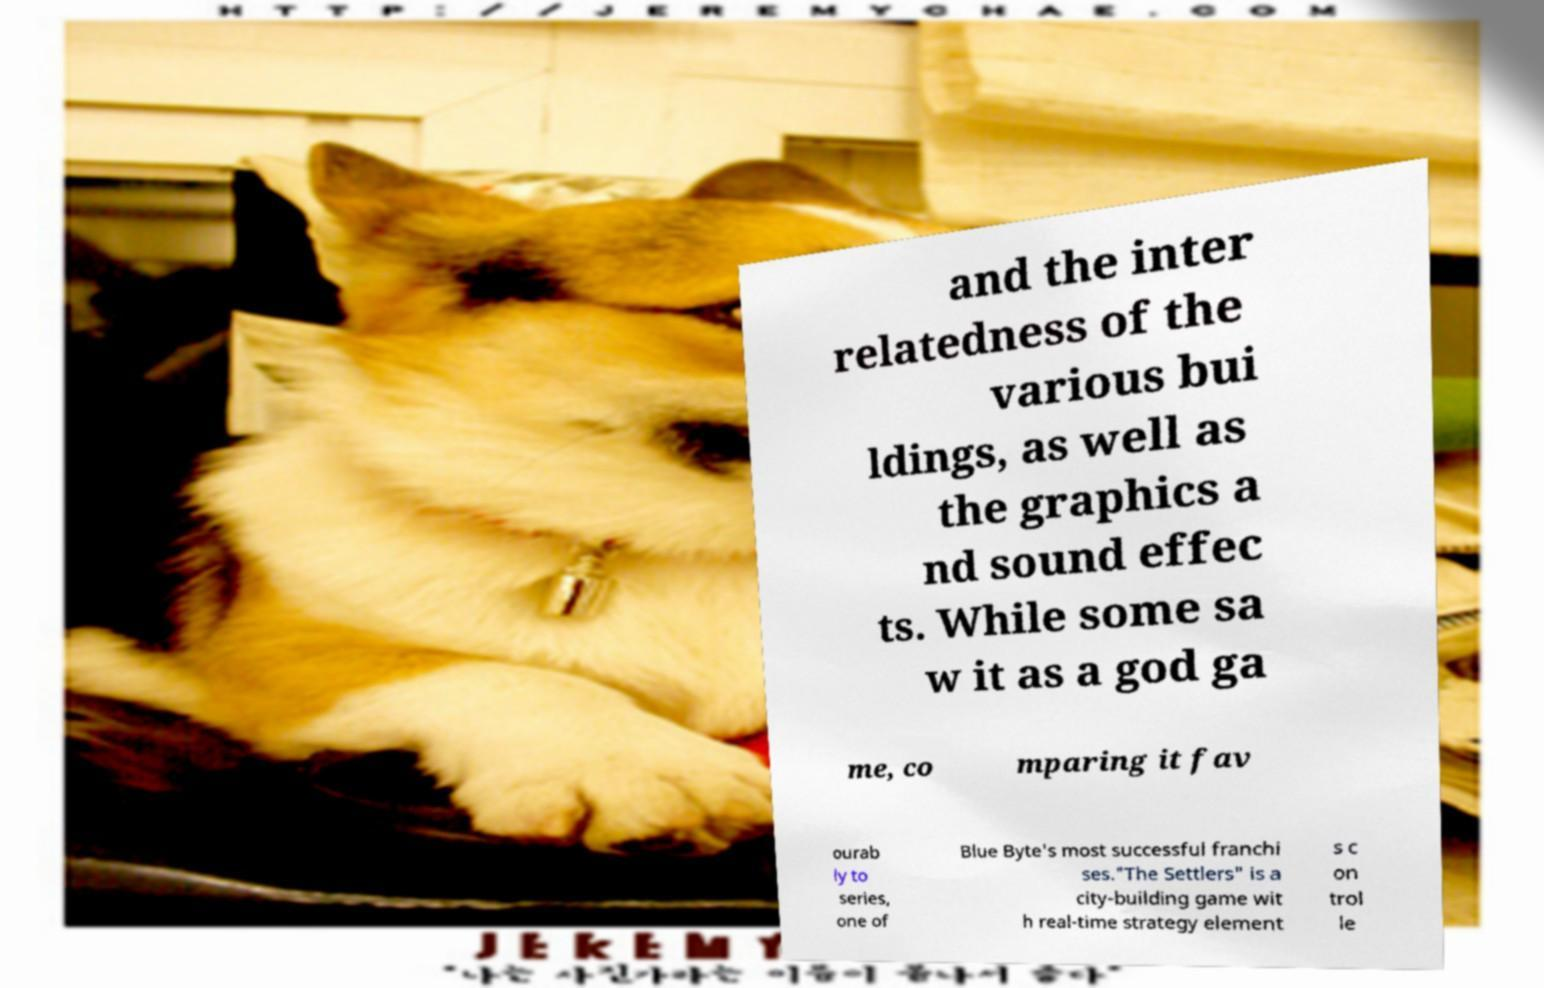I need the written content from this picture converted into text. Can you do that? and the inter relatedness of the various bui ldings, as well as the graphics a nd sound effec ts. While some sa w it as a god ga me, co mparing it fav ourab ly to series, one of Blue Byte's most successful franchi ses."The Settlers" is a city-building game wit h real-time strategy element s c on trol le 